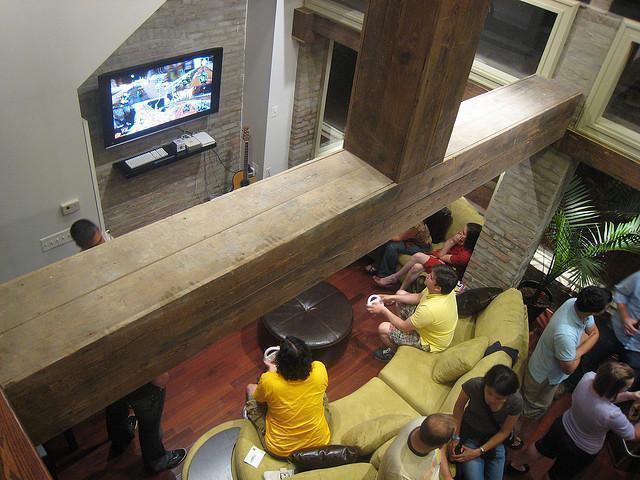The people sitting on the couch are competing in what on the television?
Indicate the correct choice and explain in the format: 'Answer: answer
Rationale: rationale.'
Options: Tekken, street fighter, mario kart, smash brothers. Answer: mario kart.
Rationale: The people are playing mario kart based on what's on the screen. 